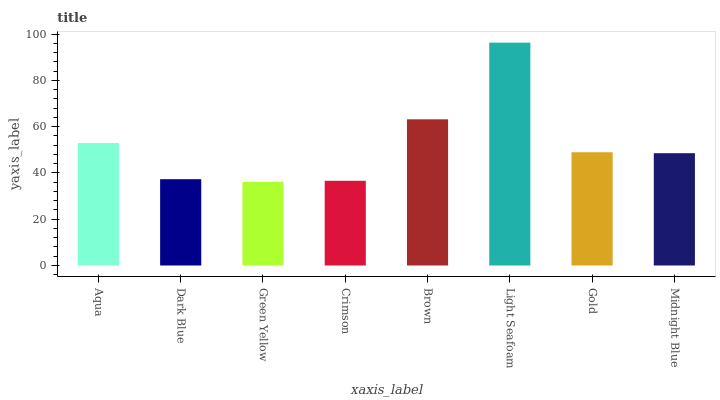Is Green Yellow the minimum?
Answer yes or no. Yes. Is Light Seafoam the maximum?
Answer yes or no. Yes. Is Dark Blue the minimum?
Answer yes or no. No. Is Dark Blue the maximum?
Answer yes or no. No. Is Aqua greater than Dark Blue?
Answer yes or no. Yes. Is Dark Blue less than Aqua?
Answer yes or no. Yes. Is Dark Blue greater than Aqua?
Answer yes or no. No. Is Aqua less than Dark Blue?
Answer yes or no. No. Is Gold the high median?
Answer yes or no. Yes. Is Midnight Blue the low median?
Answer yes or no. Yes. Is Light Seafoam the high median?
Answer yes or no. No. Is Light Seafoam the low median?
Answer yes or no. No. 